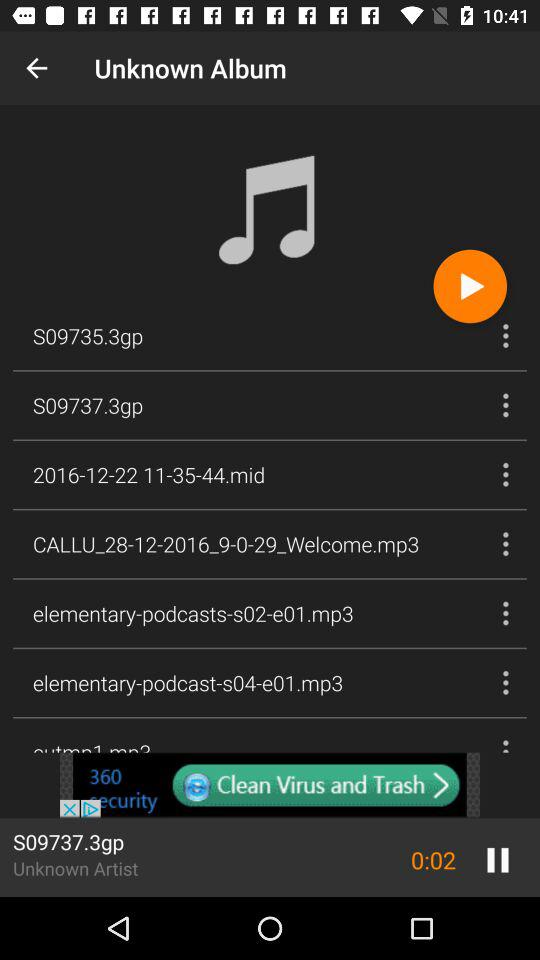Which song is playing? The song is "S09737.3gp". 